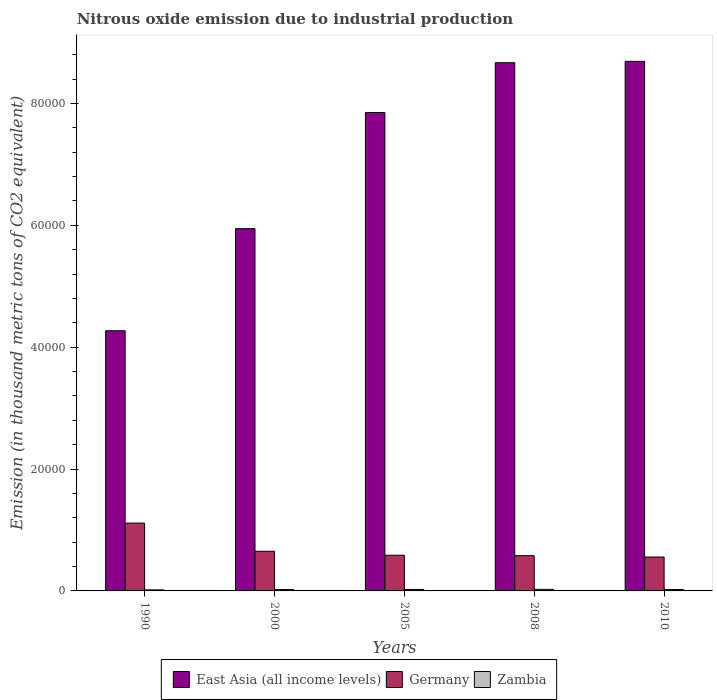How many groups of bars are there?
Provide a succinct answer. 5. Are the number of bars per tick equal to the number of legend labels?
Provide a succinct answer. Yes. Are the number of bars on each tick of the X-axis equal?
Provide a short and direct response. Yes. How many bars are there on the 5th tick from the right?
Keep it short and to the point. 3. What is the amount of nitrous oxide emitted in Germany in 2010?
Your answer should be compact. 5564. Across all years, what is the maximum amount of nitrous oxide emitted in Germany?
Provide a succinct answer. 1.11e+04. Across all years, what is the minimum amount of nitrous oxide emitted in Germany?
Keep it short and to the point. 5564. In which year was the amount of nitrous oxide emitted in East Asia (all income levels) maximum?
Offer a very short reply. 2010. What is the total amount of nitrous oxide emitted in East Asia (all income levels) in the graph?
Your answer should be compact. 3.54e+05. What is the difference between the amount of nitrous oxide emitted in Germany in 2000 and that in 2010?
Give a very brief answer. 943. What is the difference between the amount of nitrous oxide emitted in East Asia (all income levels) in 2008 and the amount of nitrous oxide emitted in Germany in 1990?
Your response must be concise. 7.56e+04. What is the average amount of nitrous oxide emitted in East Asia (all income levels) per year?
Provide a succinct answer. 7.09e+04. In the year 2000, what is the difference between the amount of nitrous oxide emitted in Zambia and amount of nitrous oxide emitted in East Asia (all income levels)?
Provide a short and direct response. -5.92e+04. In how many years, is the amount of nitrous oxide emitted in Germany greater than 60000 thousand metric tons?
Your answer should be compact. 0. What is the ratio of the amount of nitrous oxide emitted in East Asia (all income levels) in 2005 to that in 2008?
Offer a terse response. 0.91. Is the amount of nitrous oxide emitted in East Asia (all income levels) in 1990 less than that in 2005?
Offer a terse response. Yes. Is the difference between the amount of nitrous oxide emitted in Zambia in 2005 and 2010 greater than the difference between the amount of nitrous oxide emitted in East Asia (all income levels) in 2005 and 2010?
Ensure brevity in your answer.  Yes. What is the difference between the highest and the second highest amount of nitrous oxide emitted in East Asia (all income levels)?
Your response must be concise. 222.8. What is the difference between the highest and the lowest amount of nitrous oxide emitted in Zambia?
Make the answer very short. 87.1. In how many years, is the amount of nitrous oxide emitted in East Asia (all income levels) greater than the average amount of nitrous oxide emitted in East Asia (all income levels) taken over all years?
Your response must be concise. 3. Is the sum of the amount of nitrous oxide emitted in Zambia in 2000 and 2010 greater than the maximum amount of nitrous oxide emitted in Germany across all years?
Make the answer very short. No. What does the 2nd bar from the left in 2005 represents?
Your answer should be compact. Germany. What does the 1st bar from the right in 2010 represents?
Make the answer very short. Zambia. Does the graph contain any zero values?
Ensure brevity in your answer.  No. Does the graph contain grids?
Keep it short and to the point. No. Where does the legend appear in the graph?
Keep it short and to the point. Bottom center. How many legend labels are there?
Offer a terse response. 3. How are the legend labels stacked?
Your answer should be very brief. Horizontal. What is the title of the graph?
Provide a short and direct response. Nitrous oxide emission due to industrial production. What is the label or title of the Y-axis?
Offer a very short reply. Emission (in thousand metric tons of CO2 equivalent). What is the Emission (in thousand metric tons of CO2 equivalent) in East Asia (all income levels) in 1990?
Keep it short and to the point. 4.27e+04. What is the Emission (in thousand metric tons of CO2 equivalent) of Germany in 1990?
Keep it short and to the point. 1.11e+04. What is the Emission (in thousand metric tons of CO2 equivalent) of Zambia in 1990?
Your answer should be very brief. 176.2. What is the Emission (in thousand metric tons of CO2 equivalent) of East Asia (all income levels) in 2000?
Ensure brevity in your answer.  5.95e+04. What is the Emission (in thousand metric tons of CO2 equivalent) of Germany in 2000?
Ensure brevity in your answer.  6507. What is the Emission (in thousand metric tons of CO2 equivalent) in Zambia in 2000?
Your response must be concise. 226.2. What is the Emission (in thousand metric tons of CO2 equivalent) in East Asia (all income levels) in 2005?
Ensure brevity in your answer.  7.85e+04. What is the Emission (in thousand metric tons of CO2 equivalent) in Germany in 2005?
Your answer should be very brief. 5860.9. What is the Emission (in thousand metric tons of CO2 equivalent) of Zambia in 2005?
Offer a very short reply. 242.7. What is the Emission (in thousand metric tons of CO2 equivalent) in East Asia (all income levels) in 2008?
Give a very brief answer. 8.67e+04. What is the Emission (in thousand metric tons of CO2 equivalent) in Germany in 2008?
Give a very brief answer. 5785.7. What is the Emission (in thousand metric tons of CO2 equivalent) of Zambia in 2008?
Your response must be concise. 263.3. What is the Emission (in thousand metric tons of CO2 equivalent) in East Asia (all income levels) in 2010?
Offer a terse response. 8.69e+04. What is the Emission (in thousand metric tons of CO2 equivalent) of Germany in 2010?
Your response must be concise. 5564. What is the Emission (in thousand metric tons of CO2 equivalent) in Zambia in 2010?
Make the answer very short. 229.2. Across all years, what is the maximum Emission (in thousand metric tons of CO2 equivalent) of East Asia (all income levels)?
Offer a very short reply. 8.69e+04. Across all years, what is the maximum Emission (in thousand metric tons of CO2 equivalent) of Germany?
Keep it short and to the point. 1.11e+04. Across all years, what is the maximum Emission (in thousand metric tons of CO2 equivalent) of Zambia?
Make the answer very short. 263.3. Across all years, what is the minimum Emission (in thousand metric tons of CO2 equivalent) in East Asia (all income levels)?
Ensure brevity in your answer.  4.27e+04. Across all years, what is the minimum Emission (in thousand metric tons of CO2 equivalent) of Germany?
Offer a terse response. 5564. Across all years, what is the minimum Emission (in thousand metric tons of CO2 equivalent) in Zambia?
Keep it short and to the point. 176.2. What is the total Emission (in thousand metric tons of CO2 equivalent) in East Asia (all income levels) in the graph?
Offer a very short reply. 3.54e+05. What is the total Emission (in thousand metric tons of CO2 equivalent) in Germany in the graph?
Provide a short and direct response. 3.48e+04. What is the total Emission (in thousand metric tons of CO2 equivalent) in Zambia in the graph?
Offer a very short reply. 1137.6. What is the difference between the Emission (in thousand metric tons of CO2 equivalent) in East Asia (all income levels) in 1990 and that in 2000?
Make the answer very short. -1.68e+04. What is the difference between the Emission (in thousand metric tons of CO2 equivalent) in Germany in 1990 and that in 2000?
Offer a terse response. 4625.2. What is the difference between the Emission (in thousand metric tons of CO2 equivalent) in East Asia (all income levels) in 1990 and that in 2005?
Offer a very short reply. -3.58e+04. What is the difference between the Emission (in thousand metric tons of CO2 equivalent) in Germany in 1990 and that in 2005?
Provide a succinct answer. 5271.3. What is the difference between the Emission (in thousand metric tons of CO2 equivalent) of Zambia in 1990 and that in 2005?
Keep it short and to the point. -66.5. What is the difference between the Emission (in thousand metric tons of CO2 equivalent) in East Asia (all income levels) in 1990 and that in 2008?
Offer a very short reply. -4.40e+04. What is the difference between the Emission (in thousand metric tons of CO2 equivalent) of Germany in 1990 and that in 2008?
Your answer should be compact. 5346.5. What is the difference between the Emission (in thousand metric tons of CO2 equivalent) of Zambia in 1990 and that in 2008?
Your answer should be compact. -87.1. What is the difference between the Emission (in thousand metric tons of CO2 equivalent) in East Asia (all income levels) in 1990 and that in 2010?
Offer a terse response. -4.42e+04. What is the difference between the Emission (in thousand metric tons of CO2 equivalent) in Germany in 1990 and that in 2010?
Your answer should be very brief. 5568.2. What is the difference between the Emission (in thousand metric tons of CO2 equivalent) of Zambia in 1990 and that in 2010?
Make the answer very short. -53. What is the difference between the Emission (in thousand metric tons of CO2 equivalent) of East Asia (all income levels) in 2000 and that in 2005?
Your answer should be very brief. -1.91e+04. What is the difference between the Emission (in thousand metric tons of CO2 equivalent) of Germany in 2000 and that in 2005?
Offer a terse response. 646.1. What is the difference between the Emission (in thousand metric tons of CO2 equivalent) in Zambia in 2000 and that in 2005?
Your answer should be compact. -16.5. What is the difference between the Emission (in thousand metric tons of CO2 equivalent) in East Asia (all income levels) in 2000 and that in 2008?
Provide a short and direct response. -2.72e+04. What is the difference between the Emission (in thousand metric tons of CO2 equivalent) in Germany in 2000 and that in 2008?
Provide a short and direct response. 721.3. What is the difference between the Emission (in thousand metric tons of CO2 equivalent) of Zambia in 2000 and that in 2008?
Your answer should be very brief. -37.1. What is the difference between the Emission (in thousand metric tons of CO2 equivalent) of East Asia (all income levels) in 2000 and that in 2010?
Your answer should be very brief. -2.75e+04. What is the difference between the Emission (in thousand metric tons of CO2 equivalent) of Germany in 2000 and that in 2010?
Keep it short and to the point. 943. What is the difference between the Emission (in thousand metric tons of CO2 equivalent) in Zambia in 2000 and that in 2010?
Provide a short and direct response. -3. What is the difference between the Emission (in thousand metric tons of CO2 equivalent) of East Asia (all income levels) in 2005 and that in 2008?
Provide a short and direct response. -8171.9. What is the difference between the Emission (in thousand metric tons of CO2 equivalent) in Germany in 2005 and that in 2008?
Your answer should be compact. 75.2. What is the difference between the Emission (in thousand metric tons of CO2 equivalent) of Zambia in 2005 and that in 2008?
Your answer should be compact. -20.6. What is the difference between the Emission (in thousand metric tons of CO2 equivalent) in East Asia (all income levels) in 2005 and that in 2010?
Your answer should be very brief. -8394.7. What is the difference between the Emission (in thousand metric tons of CO2 equivalent) in Germany in 2005 and that in 2010?
Your response must be concise. 296.9. What is the difference between the Emission (in thousand metric tons of CO2 equivalent) of East Asia (all income levels) in 2008 and that in 2010?
Provide a short and direct response. -222.8. What is the difference between the Emission (in thousand metric tons of CO2 equivalent) of Germany in 2008 and that in 2010?
Provide a short and direct response. 221.7. What is the difference between the Emission (in thousand metric tons of CO2 equivalent) in Zambia in 2008 and that in 2010?
Provide a succinct answer. 34.1. What is the difference between the Emission (in thousand metric tons of CO2 equivalent) of East Asia (all income levels) in 1990 and the Emission (in thousand metric tons of CO2 equivalent) of Germany in 2000?
Keep it short and to the point. 3.62e+04. What is the difference between the Emission (in thousand metric tons of CO2 equivalent) in East Asia (all income levels) in 1990 and the Emission (in thousand metric tons of CO2 equivalent) in Zambia in 2000?
Your response must be concise. 4.25e+04. What is the difference between the Emission (in thousand metric tons of CO2 equivalent) of Germany in 1990 and the Emission (in thousand metric tons of CO2 equivalent) of Zambia in 2000?
Your answer should be very brief. 1.09e+04. What is the difference between the Emission (in thousand metric tons of CO2 equivalent) of East Asia (all income levels) in 1990 and the Emission (in thousand metric tons of CO2 equivalent) of Germany in 2005?
Your response must be concise. 3.68e+04. What is the difference between the Emission (in thousand metric tons of CO2 equivalent) of East Asia (all income levels) in 1990 and the Emission (in thousand metric tons of CO2 equivalent) of Zambia in 2005?
Ensure brevity in your answer.  4.25e+04. What is the difference between the Emission (in thousand metric tons of CO2 equivalent) of Germany in 1990 and the Emission (in thousand metric tons of CO2 equivalent) of Zambia in 2005?
Your answer should be very brief. 1.09e+04. What is the difference between the Emission (in thousand metric tons of CO2 equivalent) of East Asia (all income levels) in 1990 and the Emission (in thousand metric tons of CO2 equivalent) of Germany in 2008?
Your answer should be compact. 3.69e+04. What is the difference between the Emission (in thousand metric tons of CO2 equivalent) of East Asia (all income levels) in 1990 and the Emission (in thousand metric tons of CO2 equivalent) of Zambia in 2008?
Your answer should be very brief. 4.24e+04. What is the difference between the Emission (in thousand metric tons of CO2 equivalent) in Germany in 1990 and the Emission (in thousand metric tons of CO2 equivalent) in Zambia in 2008?
Your response must be concise. 1.09e+04. What is the difference between the Emission (in thousand metric tons of CO2 equivalent) in East Asia (all income levels) in 1990 and the Emission (in thousand metric tons of CO2 equivalent) in Germany in 2010?
Provide a succinct answer. 3.71e+04. What is the difference between the Emission (in thousand metric tons of CO2 equivalent) in East Asia (all income levels) in 1990 and the Emission (in thousand metric tons of CO2 equivalent) in Zambia in 2010?
Your response must be concise. 4.25e+04. What is the difference between the Emission (in thousand metric tons of CO2 equivalent) in Germany in 1990 and the Emission (in thousand metric tons of CO2 equivalent) in Zambia in 2010?
Make the answer very short. 1.09e+04. What is the difference between the Emission (in thousand metric tons of CO2 equivalent) in East Asia (all income levels) in 2000 and the Emission (in thousand metric tons of CO2 equivalent) in Germany in 2005?
Give a very brief answer. 5.36e+04. What is the difference between the Emission (in thousand metric tons of CO2 equivalent) of East Asia (all income levels) in 2000 and the Emission (in thousand metric tons of CO2 equivalent) of Zambia in 2005?
Provide a short and direct response. 5.92e+04. What is the difference between the Emission (in thousand metric tons of CO2 equivalent) of Germany in 2000 and the Emission (in thousand metric tons of CO2 equivalent) of Zambia in 2005?
Your answer should be compact. 6264.3. What is the difference between the Emission (in thousand metric tons of CO2 equivalent) of East Asia (all income levels) in 2000 and the Emission (in thousand metric tons of CO2 equivalent) of Germany in 2008?
Your response must be concise. 5.37e+04. What is the difference between the Emission (in thousand metric tons of CO2 equivalent) of East Asia (all income levels) in 2000 and the Emission (in thousand metric tons of CO2 equivalent) of Zambia in 2008?
Ensure brevity in your answer.  5.92e+04. What is the difference between the Emission (in thousand metric tons of CO2 equivalent) of Germany in 2000 and the Emission (in thousand metric tons of CO2 equivalent) of Zambia in 2008?
Your response must be concise. 6243.7. What is the difference between the Emission (in thousand metric tons of CO2 equivalent) of East Asia (all income levels) in 2000 and the Emission (in thousand metric tons of CO2 equivalent) of Germany in 2010?
Your answer should be very brief. 5.39e+04. What is the difference between the Emission (in thousand metric tons of CO2 equivalent) of East Asia (all income levels) in 2000 and the Emission (in thousand metric tons of CO2 equivalent) of Zambia in 2010?
Provide a succinct answer. 5.92e+04. What is the difference between the Emission (in thousand metric tons of CO2 equivalent) in Germany in 2000 and the Emission (in thousand metric tons of CO2 equivalent) in Zambia in 2010?
Make the answer very short. 6277.8. What is the difference between the Emission (in thousand metric tons of CO2 equivalent) of East Asia (all income levels) in 2005 and the Emission (in thousand metric tons of CO2 equivalent) of Germany in 2008?
Keep it short and to the point. 7.27e+04. What is the difference between the Emission (in thousand metric tons of CO2 equivalent) of East Asia (all income levels) in 2005 and the Emission (in thousand metric tons of CO2 equivalent) of Zambia in 2008?
Ensure brevity in your answer.  7.83e+04. What is the difference between the Emission (in thousand metric tons of CO2 equivalent) of Germany in 2005 and the Emission (in thousand metric tons of CO2 equivalent) of Zambia in 2008?
Your response must be concise. 5597.6. What is the difference between the Emission (in thousand metric tons of CO2 equivalent) of East Asia (all income levels) in 2005 and the Emission (in thousand metric tons of CO2 equivalent) of Germany in 2010?
Your answer should be very brief. 7.30e+04. What is the difference between the Emission (in thousand metric tons of CO2 equivalent) in East Asia (all income levels) in 2005 and the Emission (in thousand metric tons of CO2 equivalent) in Zambia in 2010?
Your answer should be compact. 7.83e+04. What is the difference between the Emission (in thousand metric tons of CO2 equivalent) in Germany in 2005 and the Emission (in thousand metric tons of CO2 equivalent) in Zambia in 2010?
Your answer should be very brief. 5631.7. What is the difference between the Emission (in thousand metric tons of CO2 equivalent) of East Asia (all income levels) in 2008 and the Emission (in thousand metric tons of CO2 equivalent) of Germany in 2010?
Ensure brevity in your answer.  8.11e+04. What is the difference between the Emission (in thousand metric tons of CO2 equivalent) of East Asia (all income levels) in 2008 and the Emission (in thousand metric tons of CO2 equivalent) of Zambia in 2010?
Give a very brief answer. 8.65e+04. What is the difference between the Emission (in thousand metric tons of CO2 equivalent) in Germany in 2008 and the Emission (in thousand metric tons of CO2 equivalent) in Zambia in 2010?
Provide a short and direct response. 5556.5. What is the average Emission (in thousand metric tons of CO2 equivalent) in East Asia (all income levels) per year?
Give a very brief answer. 7.09e+04. What is the average Emission (in thousand metric tons of CO2 equivalent) of Germany per year?
Offer a very short reply. 6969.96. What is the average Emission (in thousand metric tons of CO2 equivalent) in Zambia per year?
Ensure brevity in your answer.  227.52. In the year 1990, what is the difference between the Emission (in thousand metric tons of CO2 equivalent) of East Asia (all income levels) and Emission (in thousand metric tons of CO2 equivalent) of Germany?
Offer a terse response. 3.16e+04. In the year 1990, what is the difference between the Emission (in thousand metric tons of CO2 equivalent) in East Asia (all income levels) and Emission (in thousand metric tons of CO2 equivalent) in Zambia?
Your response must be concise. 4.25e+04. In the year 1990, what is the difference between the Emission (in thousand metric tons of CO2 equivalent) in Germany and Emission (in thousand metric tons of CO2 equivalent) in Zambia?
Give a very brief answer. 1.10e+04. In the year 2000, what is the difference between the Emission (in thousand metric tons of CO2 equivalent) in East Asia (all income levels) and Emission (in thousand metric tons of CO2 equivalent) in Germany?
Make the answer very short. 5.29e+04. In the year 2000, what is the difference between the Emission (in thousand metric tons of CO2 equivalent) in East Asia (all income levels) and Emission (in thousand metric tons of CO2 equivalent) in Zambia?
Give a very brief answer. 5.92e+04. In the year 2000, what is the difference between the Emission (in thousand metric tons of CO2 equivalent) in Germany and Emission (in thousand metric tons of CO2 equivalent) in Zambia?
Give a very brief answer. 6280.8. In the year 2005, what is the difference between the Emission (in thousand metric tons of CO2 equivalent) in East Asia (all income levels) and Emission (in thousand metric tons of CO2 equivalent) in Germany?
Offer a very short reply. 7.27e+04. In the year 2005, what is the difference between the Emission (in thousand metric tons of CO2 equivalent) of East Asia (all income levels) and Emission (in thousand metric tons of CO2 equivalent) of Zambia?
Your answer should be very brief. 7.83e+04. In the year 2005, what is the difference between the Emission (in thousand metric tons of CO2 equivalent) in Germany and Emission (in thousand metric tons of CO2 equivalent) in Zambia?
Provide a succinct answer. 5618.2. In the year 2008, what is the difference between the Emission (in thousand metric tons of CO2 equivalent) in East Asia (all income levels) and Emission (in thousand metric tons of CO2 equivalent) in Germany?
Offer a very short reply. 8.09e+04. In the year 2008, what is the difference between the Emission (in thousand metric tons of CO2 equivalent) in East Asia (all income levels) and Emission (in thousand metric tons of CO2 equivalent) in Zambia?
Your answer should be compact. 8.64e+04. In the year 2008, what is the difference between the Emission (in thousand metric tons of CO2 equivalent) in Germany and Emission (in thousand metric tons of CO2 equivalent) in Zambia?
Give a very brief answer. 5522.4. In the year 2010, what is the difference between the Emission (in thousand metric tons of CO2 equivalent) of East Asia (all income levels) and Emission (in thousand metric tons of CO2 equivalent) of Germany?
Give a very brief answer. 8.13e+04. In the year 2010, what is the difference between the Emission (in thousand metric tons of CO2 equivalent) of East Asia (all income levels) and Emission (in thousand metric tons of CO2 equivalent) of Zambia?
Your answer should be very brief. 8.67e+04. In the year 2010, what is the difference between the Emission (in thousand metric tons of CO2 equivalent) of Germany and Emission (in thousand metric tons of CO2 equivalent) of Zambia?
Provide a short and direct response. 5334.8. What is the ratio of the Emission (in thousand metric tons of CO2 equivalent) in East Asia (all income levels) in 1990 to that in 2000?
Provide a succinct answer. 0.72. What is the ratio of the Emission (in thousand metric tons of CO2 equivalent) in Germany in 1990 to that in 2000?
Provide a succinct answer. 1.71. What is the ratio of the Emission (in thousand metric tons of CO2 equivalent) of Zambia in 1990 to that in 2000?
Offer a very short reply. 0.78. What is the ratio of the Emission (in thousand metric tons of CO2 equivalent) of East Asia (all income levels) in 1990 to that in 2005?
Offer a very short reply. 0.54. What is the ratio of the Emission (in thousand metric tons of CO2 equivalent) of Germany in 1990 to that in 2005?
Your response must be concise. 1.9. What is the ratio of the Emission (in thousand metric tons of CO2 equivalent) in Zambia in 1990 to that in 2005?
Keep it short and to the point. 0.73. What is the ratio of the Emission (in thousand metric tons of CO2 equivalent) of East Asia (all income levels) in 1990 to that in 2008?
Make the answer very short. 0.49. What is the ratio of the Emission (in thousand metric tons of CO2 equivalent) in Germany in 1990 to that in 2008?
Offer a terse response. 1.92. What is the ratio of the Emission (in thousand metric tons of CO2 equivalent) of Zambia in 1990 to that in 2008?
Your response must be concise. 0.67. What is the ratio of the Emission (in thousand metric tons of CO2 equivalent) in East Asia (all income levels) in 1990 to that in 2010?
Ensure brevity in your answer.  0.49. What is the ratio of the Emission (in thousand metric tons of CO2 equivalent) in Germany in 1990 to that in 2010?
Provide a succinct answer. 2. What is the ratio of the Emission (in thousand metric tons of CO2 equivalent) in Zambia in 1990 to that in 2010?
Offer a very short reply. 0.77. What is the ratio of the Emission (in thousand metric tons of CO2 equivalent) in East Asia (all income levels) in 2000 to that in 2005?
Provide a succinct answer. 0.76. What is the ratio of the Emission (in thousand metric tons of CO2 equivalent) in Germany in 2000 to that in 2005?
Your answer should be very brief. 1.11. What is the ratio of the Emission (in thousand metric tons of CO2 equivalent) in Zambia in 2000 to that in 2005?
Your answer should be compact. 0.93. What is the ratio of the Emission (in thousand metric tons of CO2 equivalent) of East Asia (all income levels) in 2000 to that in 2008?
Offer a terse response. 0.69. What is the ratio of the Emission (in thousand metric tons of CO2 equivalent) in Germany in 2000 to that in 2008?
Your response must be concise. 1.12. What is the ratio of the Emission (in thousand metric tons of CO2 equivalent) of Zambia in 2000 to that in 2008?
Your answer should be compact. 0.86. What is the ratio of the Emission (in thousand metric tons of CO2 equivalent) of East Asia (all income levels) in 2000 to that in 2010?
Offer a very short reply. 0.68. What is the ratio of the Emission (in thousand metric tons of CO2 equivalent) in Germany in 2000 to that in 2010?
Offer a very short reply. 1.17. What is the ratio of the Emission (in thousand metric tons of CO2 equivalent) in Zambia in 2000 to that in 2010?
Keep it short and to the point. 0.99. What is the ratio of the Emission (in thousand metric tons of CO2 equivalent) in East Asia (all income levels) in 2005 to that in 2008?
Your response must be concise. 0.91. What is the ratio of the Emission (in thousand metric tons of CO2 equivalent) in Zambia in 2005 to that in 2008?
Offer a terse response. 0.92. What is the ratio of the Emission (in thousand metric tons of CO2 equivalent) of East Asia (all income levels) in 2005 to that in 2010?
Keep it short and to the point. 0.9. What is the ratio of the Emission (in thousand metric tons of CO2 equivalent) of Germany in 2005 to that in 2010?
Your response must be concise. 1.05. What is the ratio of the Emission (in thousand metric tons of CO2 equivalent) in Zambia in 2005 to that in 2010?
Keep it short and to the point. 1.06. What is the ratio of the Emission (in thousand metric tons of CO2 equivalent) in East Asia (all income levels) in 2008 to that in 2010?
Provide a short and direct response. 1. What is the ratio of the Emission (in thousand metric tons of CO2 equivalent) in Germany in 2008 to that in 2010?
Provide a short and direct response. 1.04. What is the ratio of the Emission (in thousand metric tons of CO2 equivalent) in Zambia in 2008 to that in 2010?
Your response must be concise. 1.15. What is the difference between the highest and the second highest Emission (in thousand metric tons of CO2 equivalent) in East Asia (all income levels)?
Offer a very short reply. 222.8. What is the difference between the highest and the second highest Emission (in thousand metric tons of CO2 equivalent) of Germany?
Give a very brief answer. 4625.2. What is the difference between the highest and the second highest Emission (in thousand metric tons of CO2 equivalent) in Zambia?
Provide a succinct answer. 20.6. What is the difference between the highest and the lowest Emission (in thousand metric tons of CO2 equivalent) of East Asia (all income levels)?
Provide a succinct answer. 4.42e+04. What is the difference between the highest and the lowest Emission (in thousand metric tons of CO2 equivalent) in Germany?
Your response must be concise. 5568.2. What is the difference between the highest and the lowest Emission (in thousand metric tons of CO2 equivalent) of Zambia?
Ensure brevity in your answer.  87.1. 